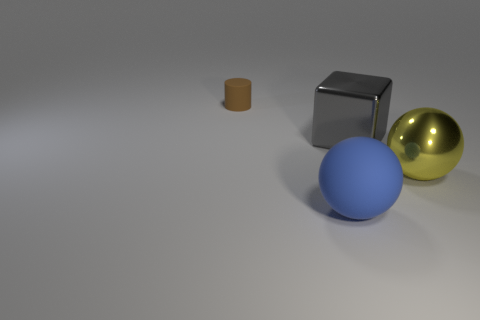Is there any other thing that is the same size as the brown rubber object?
Offer a very short reply. No. Are there any other things that have the same material as the blue sphere?
Ensure brevity in your answer.  Yes. What is the color of the other thing that is the same shape as the blue rubber object?
Provide a short and direct response. Yellow. Is the large rubber ball the same color as the large block?
Keep it short and to the point. No. There is a thing behind the big shiny cube; what is it made of?
Your response must be concise. Rubber. What number of tiny objects are either gray metallic cubes or rubber things?
Keep it short and to the point. 1. Is there a tiny object that has the same material as the big yellow object?
Your response must be concise. No. There is a thing that is to the right of the gray thing; is its size the same as the small cylinder?
Your answer should be compact. No. There is a big thing in front of the big ball to the right of the blue object; is there a large shiny thing to the right of it?
Ensure brevity in your answer.  Yes. How many rubber objects are small red cylinders or gray things?
Keep it short and to the point. 0. 